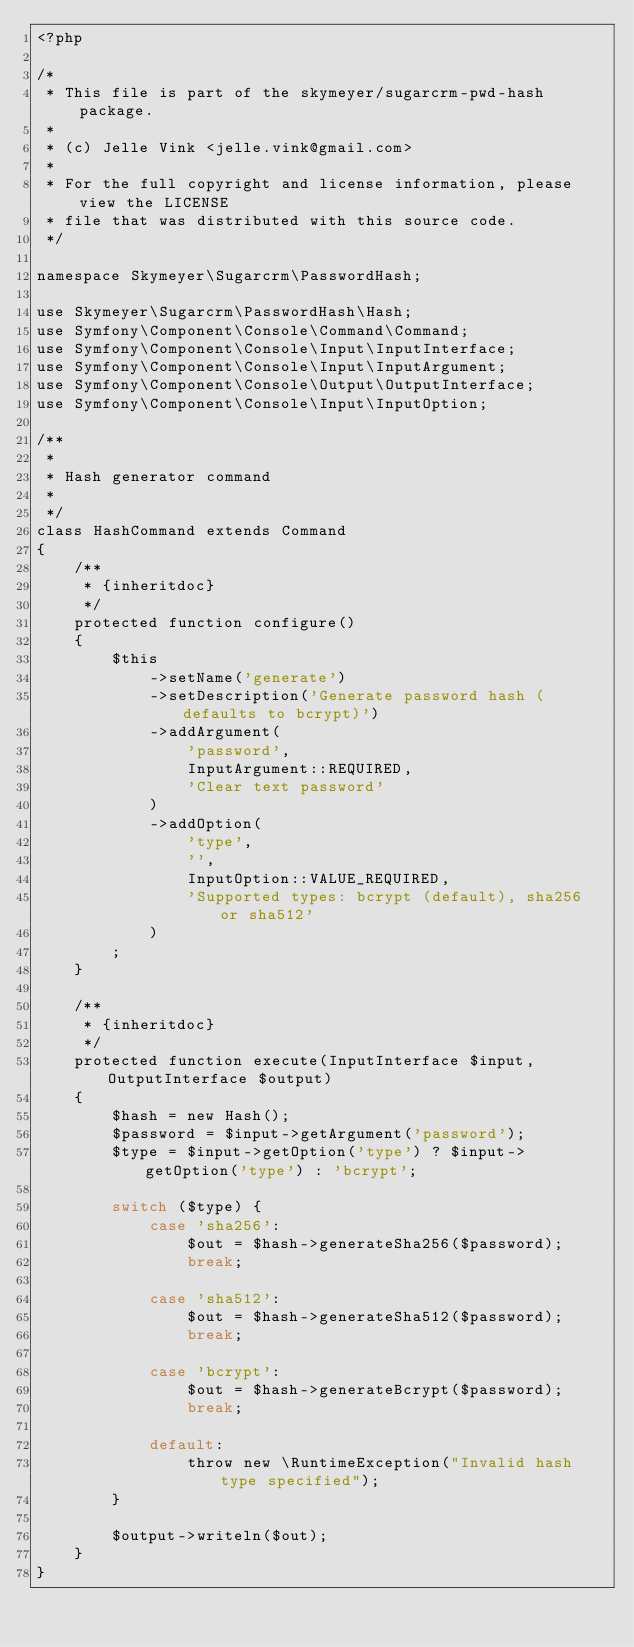Convert code to text. <code><loc_0><loc_0><loc_500><loc_500><_PHP_><?php

/*
 * This file is part of the skymeyer/sugarcrm-pwd-hash package.
 *
 * (c) Jelle Vink <jelle.vink@gmail.com>
 *
 * For the full copyright and license information, please view the LICENSE
 * file that was distributed with this source code.
 */

namespace Skymeyer\Sugarcrm\PasswordHash;

use Skymeyer\Sugarcrm\PasswordHash\Hash;
use Symfony\Component\Console\Command\Command;
use Symfony\Component\Console\Input\InputInterface;
use Symfony\Component\Console\Input\InputArgument;
use Symfony\Component\Console\Output\OutputInterface;
use Symfony\Component\Console\Input\InputOption;

/**
 *
 * Hash generator command
 *
 */
class HashCommand extends Command
{
    /**
     * {inheritdoc}
     */
    protected function configure()
    {
        $this
            ->setName('generate')
            ->setDescription('Generate password hash (defaults to bcrypt)')
            ->addArgument(
                'password',
                InputArgument::REQUIRED,
                'Clear text password'
            )
            ->addOption(
                'type',
                '',
                InputOption::VALUE_REQUIRED,
                'Supported types: bcrypt (default), sha256 or sha512'
            )
        ;
    }

    /**
     * {inheritdoc}
     */
    protected function execute(InputInterface $input, OutputInterface $output)
    {
        $hash = new Hash();
        $password = $input->getArgument('password');
        $type = $input->getOption('type') ? $input->getOption('type') : 'bcrypt';

        switch ($type) {
            case 'sha256':
                $out = $hash->generateSha256($password);
                break;

            case 'sha512':
                $out = $hash->generateSha512($password);
                break;

            case 'bcrypt':
                $out = $hash->generateBcrypt($password);
                break;

            default:
                throw new \RuntimeException("Invalid hash type specified");
        }

        $output->writeln($out);
    }
}
</code> 